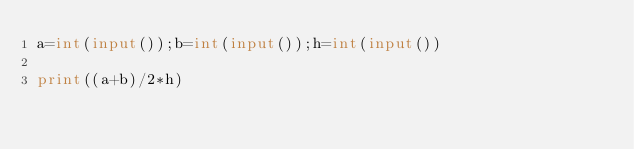<code> <loc_0><loc_0><loc_500><loc_500><_Python_>a=int(input());b=int(input());h=int(input())

print((a+b)/2*h)</code> 